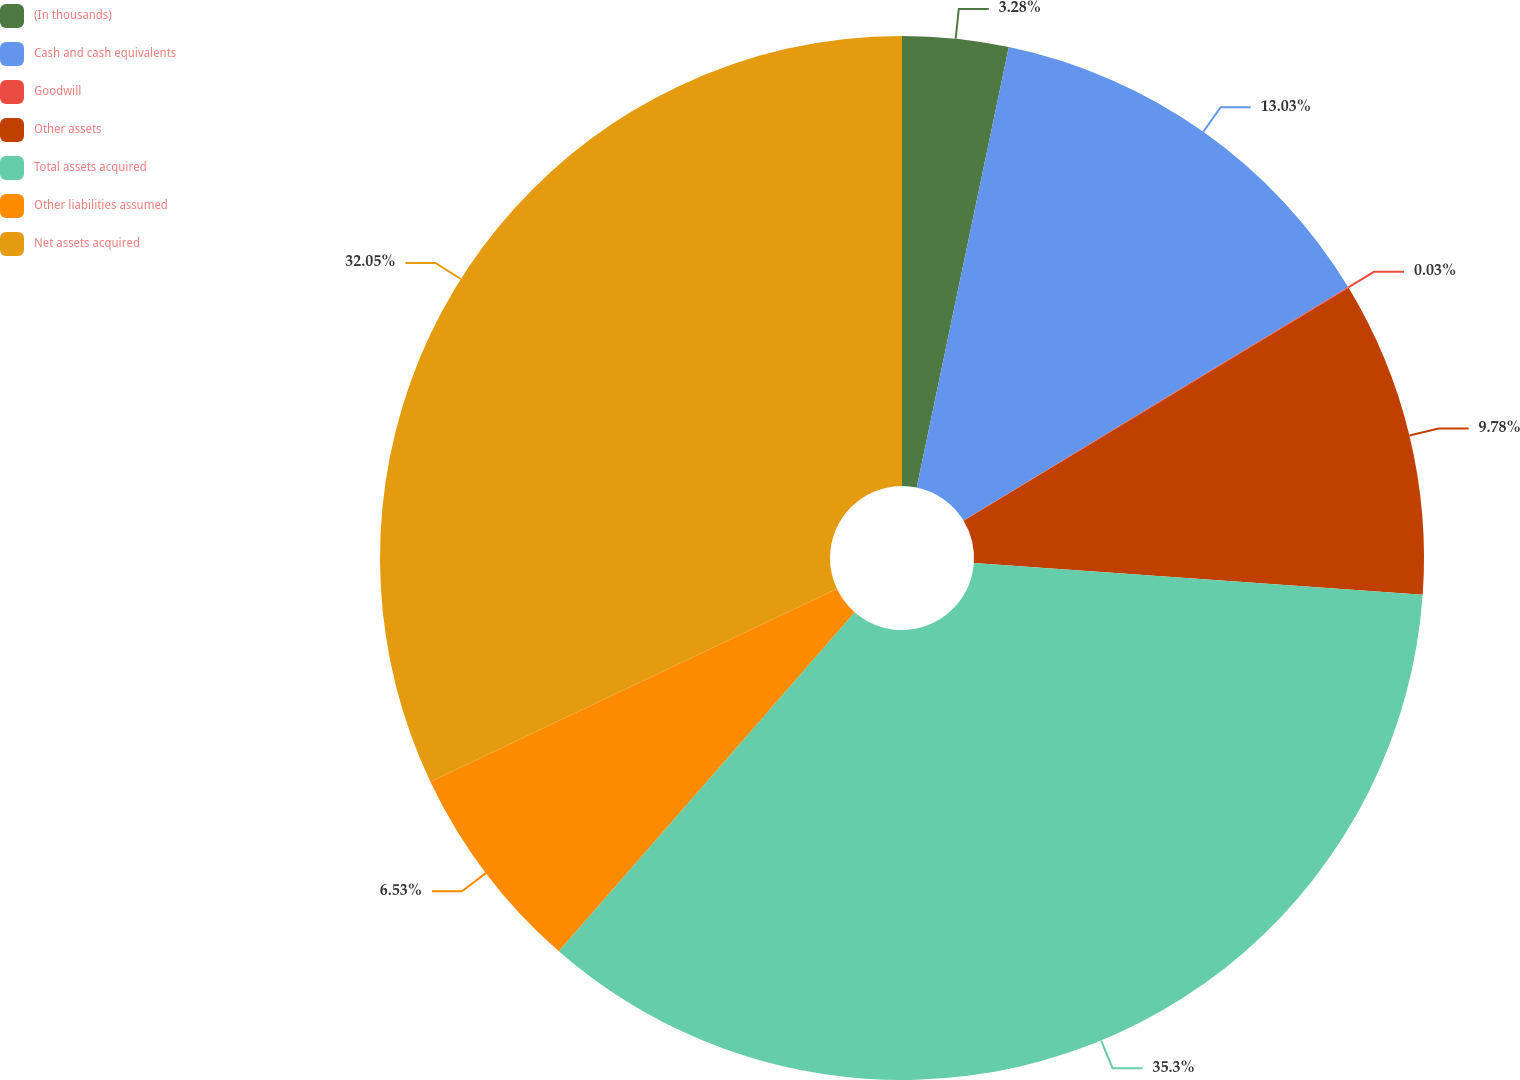<chart> <loc_0><loc_0><loc_500><loc_500><pie_chart><fcel>(In thousands)<fcel>Cash and cash equivalents<fcel>Goodwill<fcel>Other assets<fcel>Total assets acquired<fcel>Other liabilities assumed<fcel>Net assets acquired<nl><fcel>3.28%<fcel>13.03%<fcel>0.03%<fcel>9.78%<fcel>35.3%<fcel>6.53%<fcel>32.05%<nl></chart> 